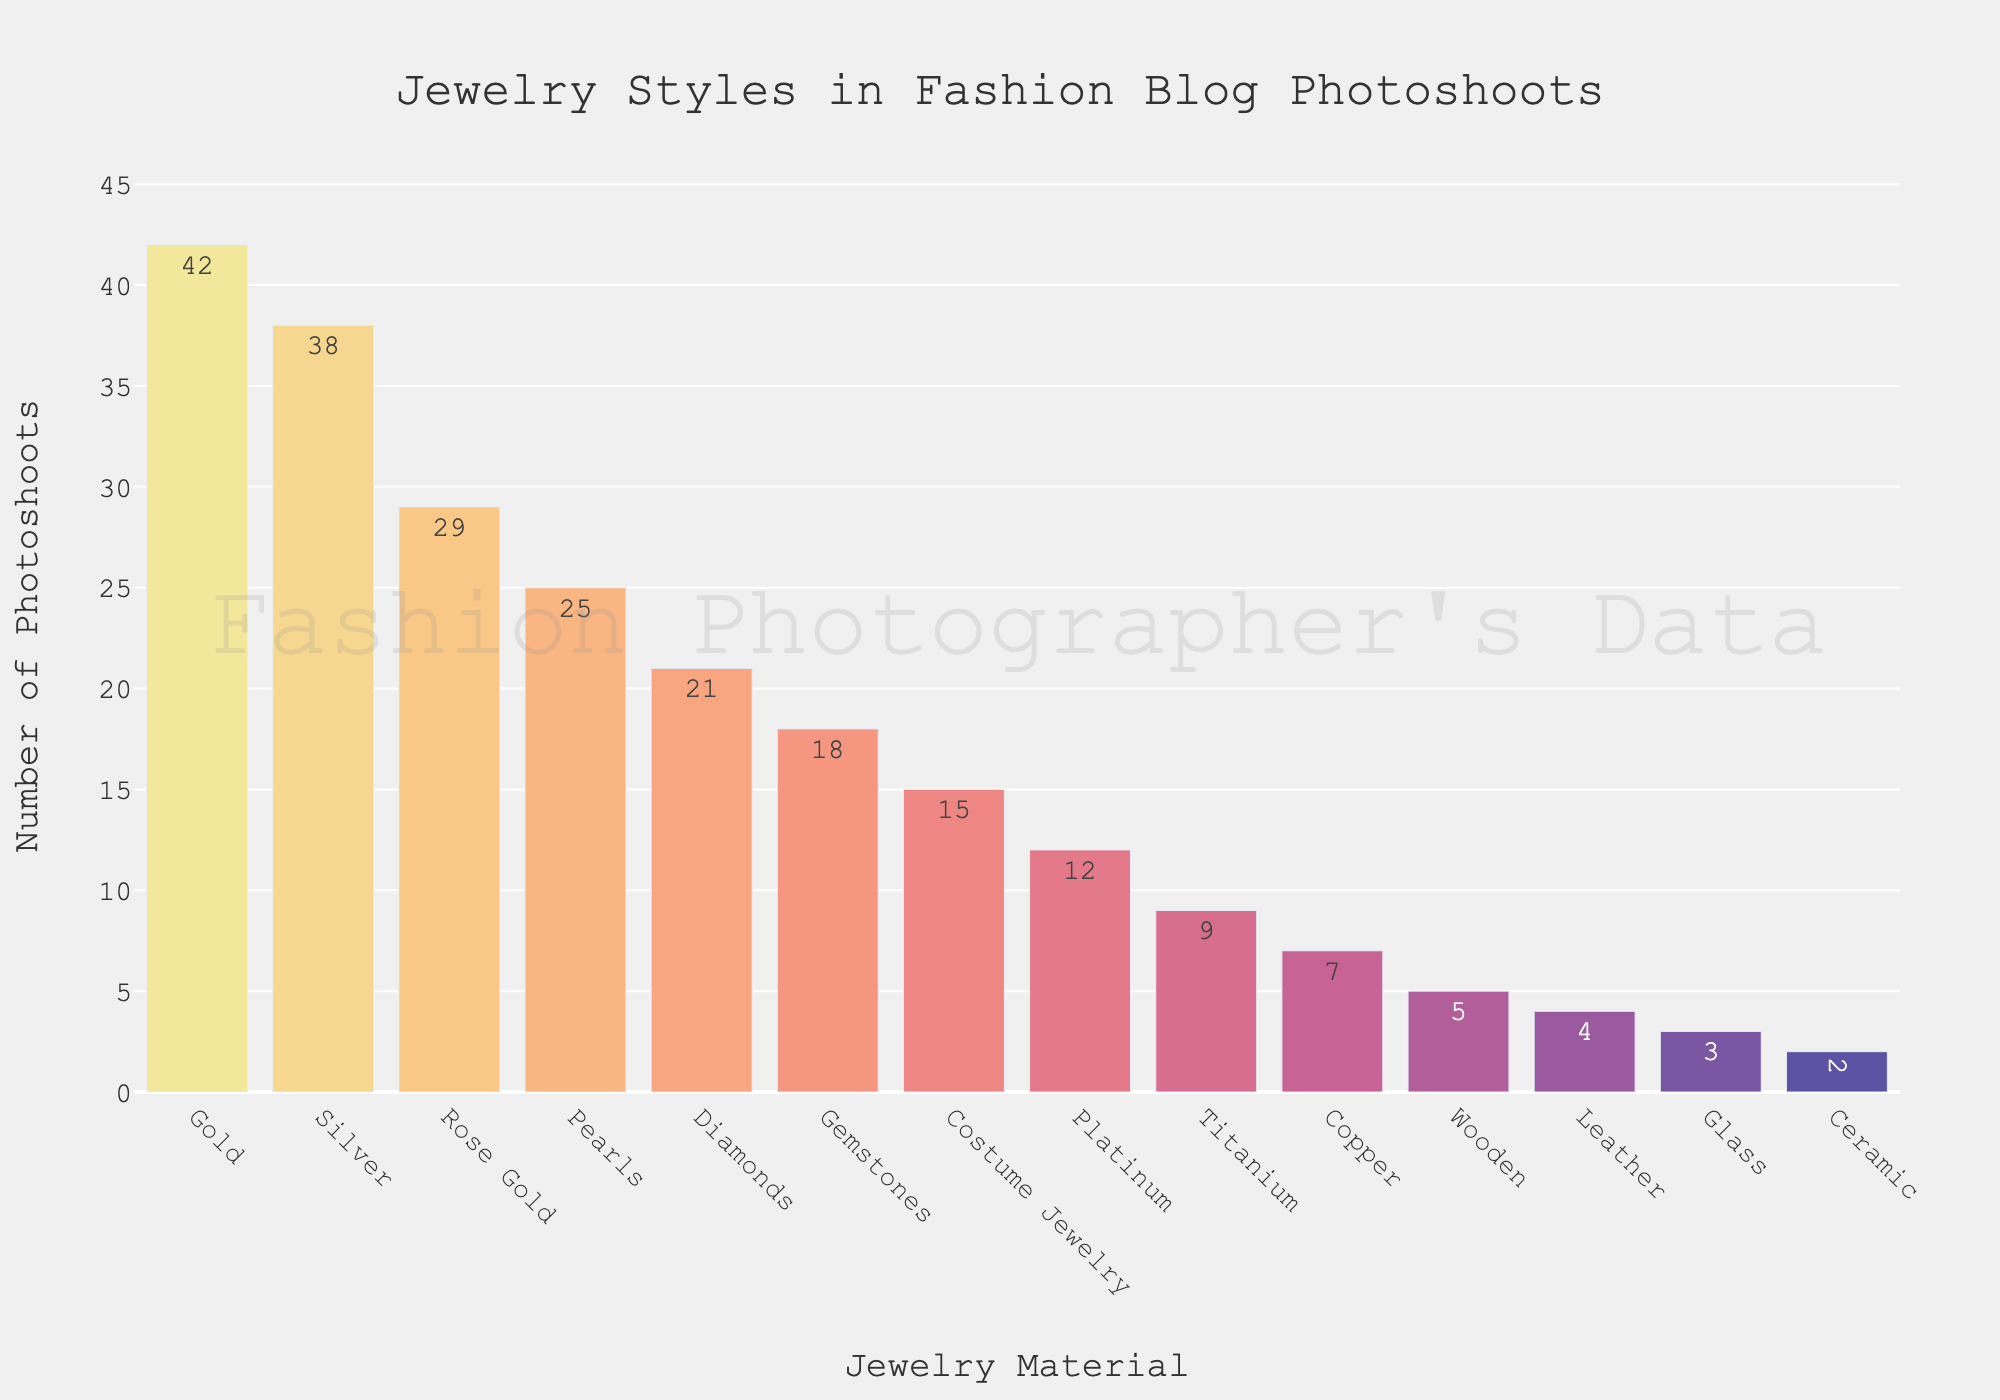What's the most popular jewelry material featured in photoshoots? The tallest bar in the chart represents the number of photoshoots by material. The tallest bar corresponds to Gold.
Answer: Gold What's the difference in the number of photoshoots between Gold and Silver? The bar representing Gold shows 42 photoshoots, and Silver shows 38 photoshoots. Subtracting the number of Silver photoshoots from Gold gives 42 - 38.
Answer: 4 Which jewelry material is featured in the fewest photoshoots? The shortest bar in the chart represents the number of photoshoots by material. The shortest bar corresponds to Ceramic.
Answer: Ceramic What's the combined number of photoshoots for Rose Gold and Pearls? The bar for Rose Gold shows 29 photoshoots, and Pearls shows 25 photoshoots. Adding these together gives 29 + 25.
Answer: 54 How many more photoshoots feature Diamonds compared to Costume Jewelry? The bar for Diamonds shows 21 photoshoots, and Costume Jewelry shows 15 photoshoots. Subtracting the number of Costume Jewelry photoshoots from Diamonds gives 21 - 15.
Answer: 6 Which material has more photoshoots, Gemstones or Platinum, and by how many? The bar for Gemstones shows 18 photoshoots, while Platinum shows 12. Subtracting Platinum’s photoshoots from Gemstones' gives 18 - 12.
Answer: Gemstones, 6 What is the average number of photoshoots for the materials: Titanium, Copper, and Wooden? The bars show Titanium with 9, Copper with 7, and Wooden with 5 photoshoots. The sum is 9 + 7 + 5 = 21. Dividing by the 3 materials gives an average of 21 / 3.
Answer: 7 What is the total number of photoshoots for the top three most popular materials? The top three bars are Gold with 42, Silver with 38, and Rose Gold with 29 photoshoots. Adding these together gives 42 + 38 + 29.
Answer: 109 How many photoshoots more does Gold have compared to Pearls and Copper combined? Gold has 42 photoshoots, Pearls have 25, and Copper 7. The combined number for Pearls and Copper is 25 + 7 = 32. The difference is 42 - 32.
Answer: 10 Are there more photoshoots featuring Wooden or Leather jewelry, and by how many? Wooden jewelry has 5 photoshoots, and Leather has 4. The difference is 5 - 4.
Answer: Wooden, 1 